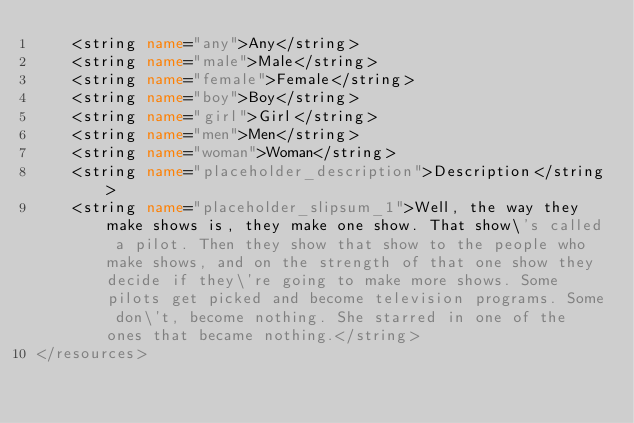Convert code to text. <code><loc_0><loc_0><loc_500><loc_500><_XML_>    <string name="any">Any</string>
    <string name="male">Male</string>
    <string name="female">Female</string>
    <string name="boy">Boy</string>
    <string name="girl">Girl</string>
    <string name="men">Men</string>
    <string name="woman">Woman</string>
    <string name="placeholder_description">Description</string>
    <string name="placeholder_slipsum_1">Well, the way they make shows is, they make one show. That show\'s called a pilot. Then they show that show to the people who make shows, and on the strength of that one show they decide if they\'re going to make more shows. Some pilots get picked and become television programs. Some don\'t, become nothing. She starred in one of the ones that became nothing.</string>
</resources>
</code> 